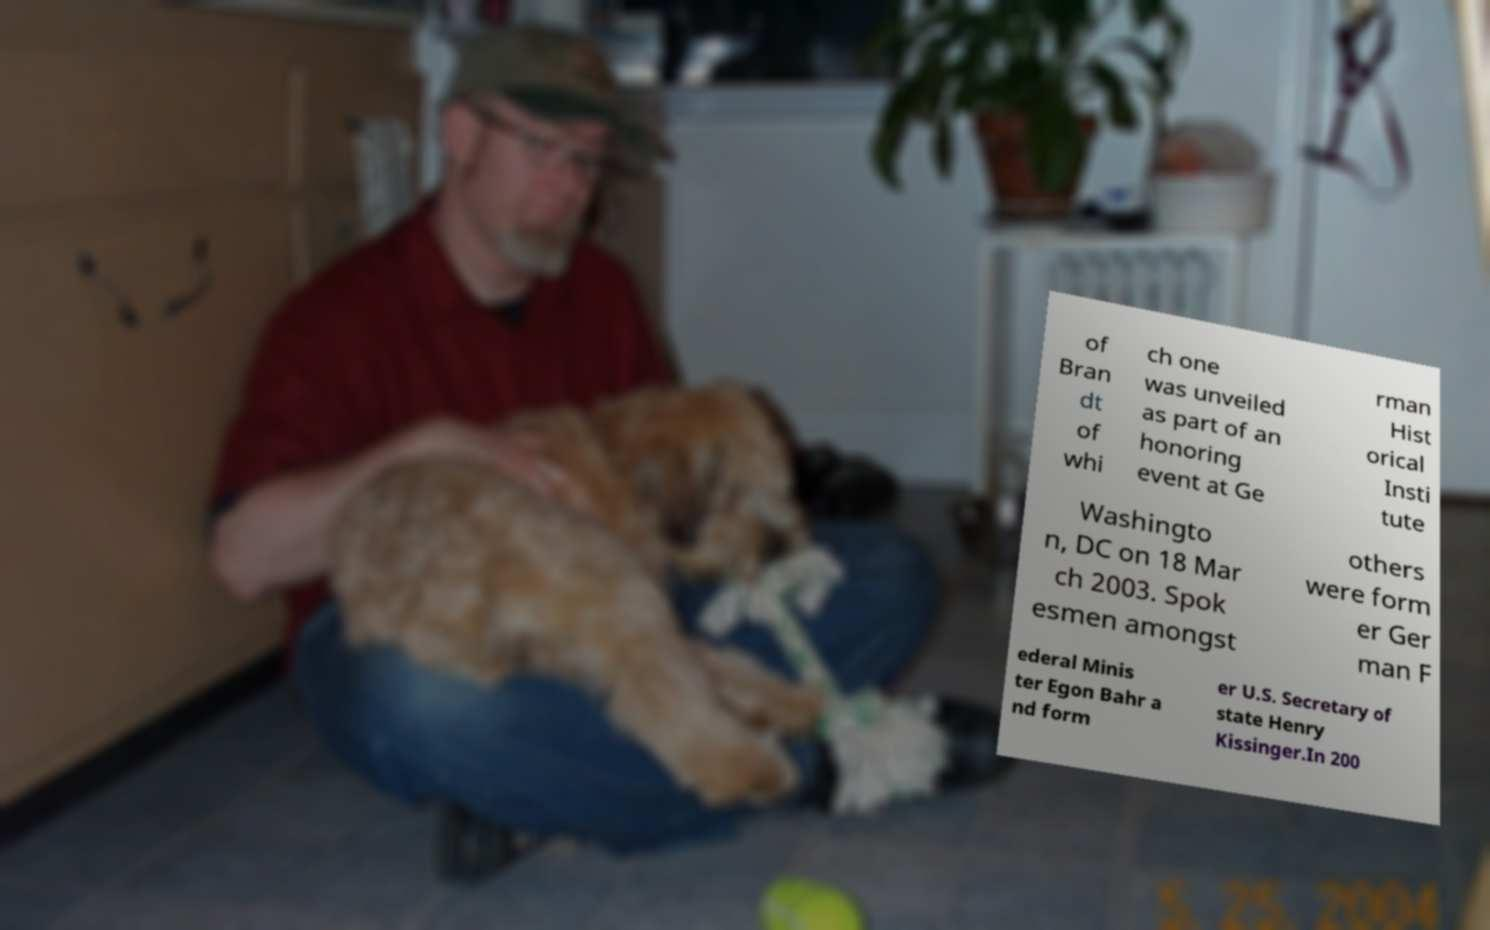Please identify and transcribe the text found in this image. of Bran dt of whi ch one was unveiled as part of an honoring event at Ge rman Hist orical Insti tute Washingto n, DC on 18 Mar ch 2003. Spok esmen amongst others were form er Ger man F ederal Minis ter Egon Bahr a nd form er U.S. Secretary of state Henry Kissinger.In 200 